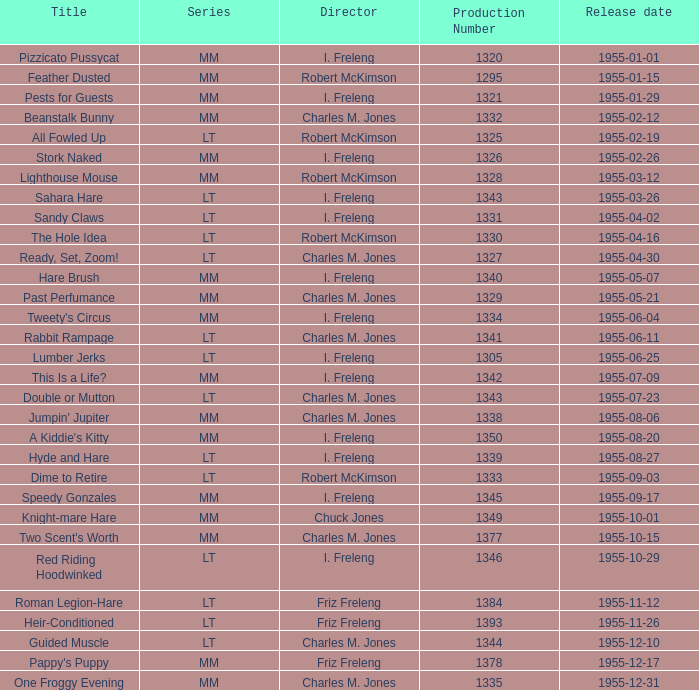What is the title of the work with a production number exceeding 1334, launched on 1955-08-27? Hyde and Hare. 